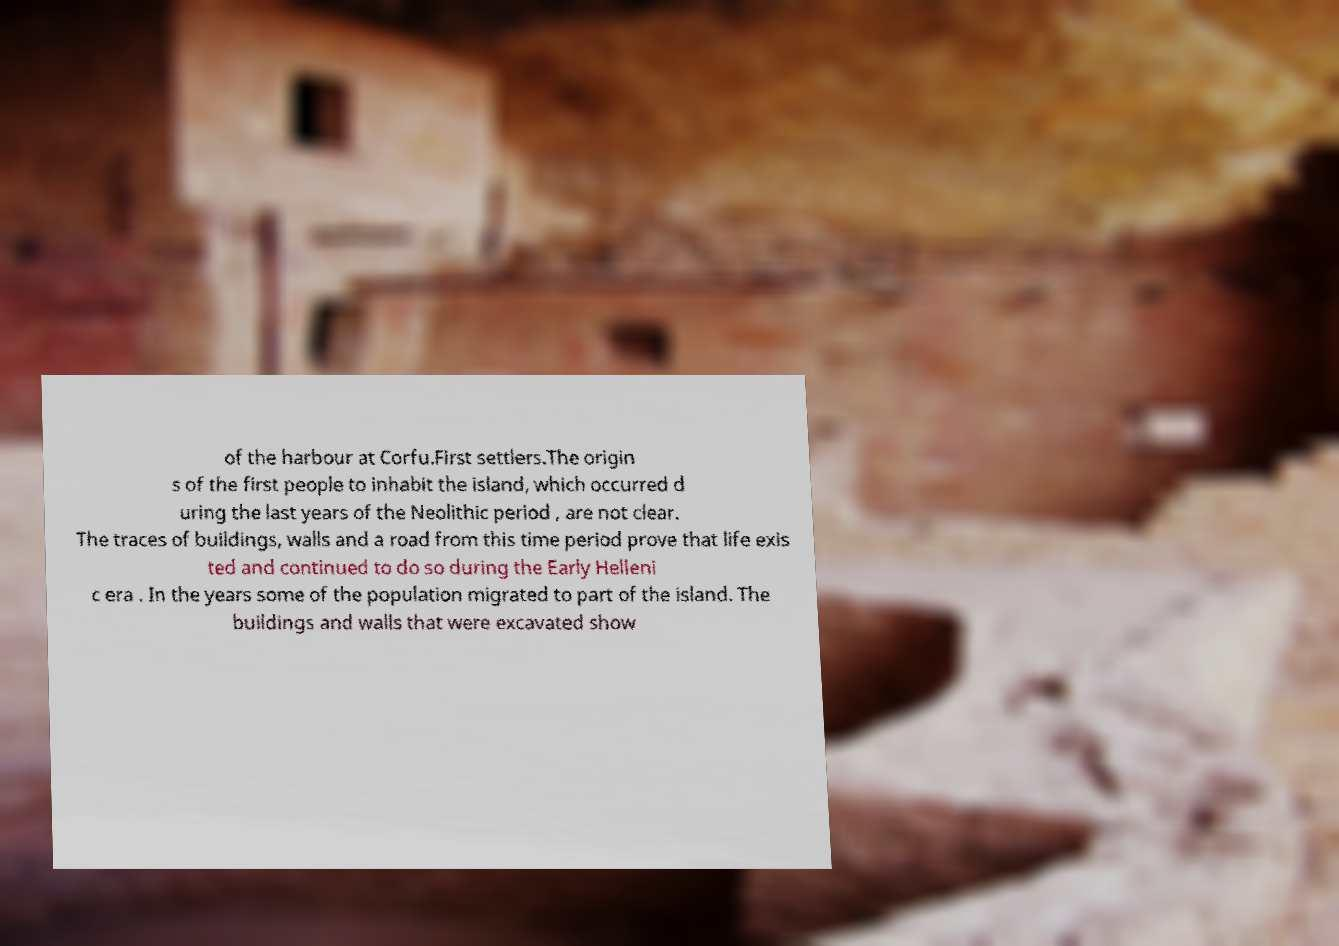Could you assist in decoding the text presented in this image and type it out clearly? of the harbour at Corfu.First settlers.The origin s of the first people to inhabit the island, which occurred d uring the last years of the Neolithic period , are not clear. The traces of buildings, walls and a road from this time period prove that life exis ted and continued to do so during the Early Helleni c era . In the years some of the population migrated to part of the island. The buildings and walls that were excavated show 